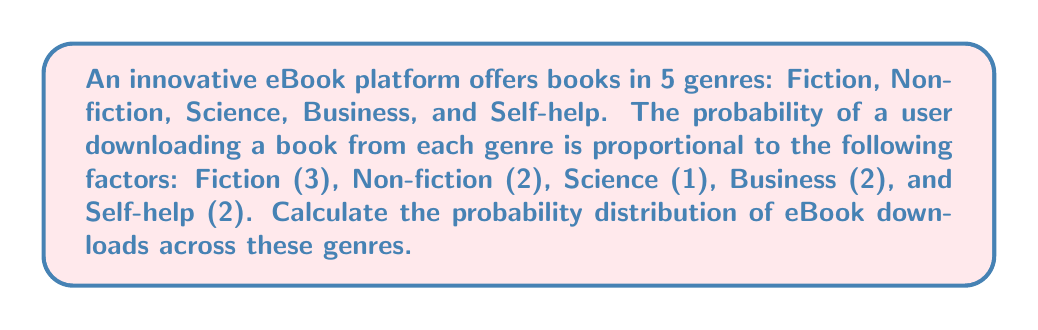Give your solution to this math problem. To solve this problem, we'll follow these steps:

1) First, we need to calculate the total sum of all factors:
   $$ \text{Total} = 3 + 2 + 1 + 2 + 2 = 10 $$

2) Then, we can calculate the probability for each genre by dividing its factor by the total:

   Fiction: $$ P(\text{Fiction}) = \frac{3}{10} = 0.3 $$
   
   Non-fiction: $$ P(\text{Non-fiction}) = \frac{2}{10} = 0.2 $$
   
   Science: $$ P(\text{Science}) = \frac{1}{10} = 0.1 $$
   
   Business: $$ P(\text{Business}) = \frac{2}{10} = 0.2 $$
   
   Self-help: $$ P(\text{Self-help}) = \frac{2}{10} = 0.2 $$

3) We can verify that the sum of all probabilities equals 1:
   $$ 0.3 + 0.2 + 0.1 + 0.2 + 0.2 = 1 $$

This gives us the probability distribution of eBook downloads across the different genres.
Answer: Fiction: 0.3, Non-fiction: 0.2, Science: 0.1, Business: 0.2, Self-help: 0.2 